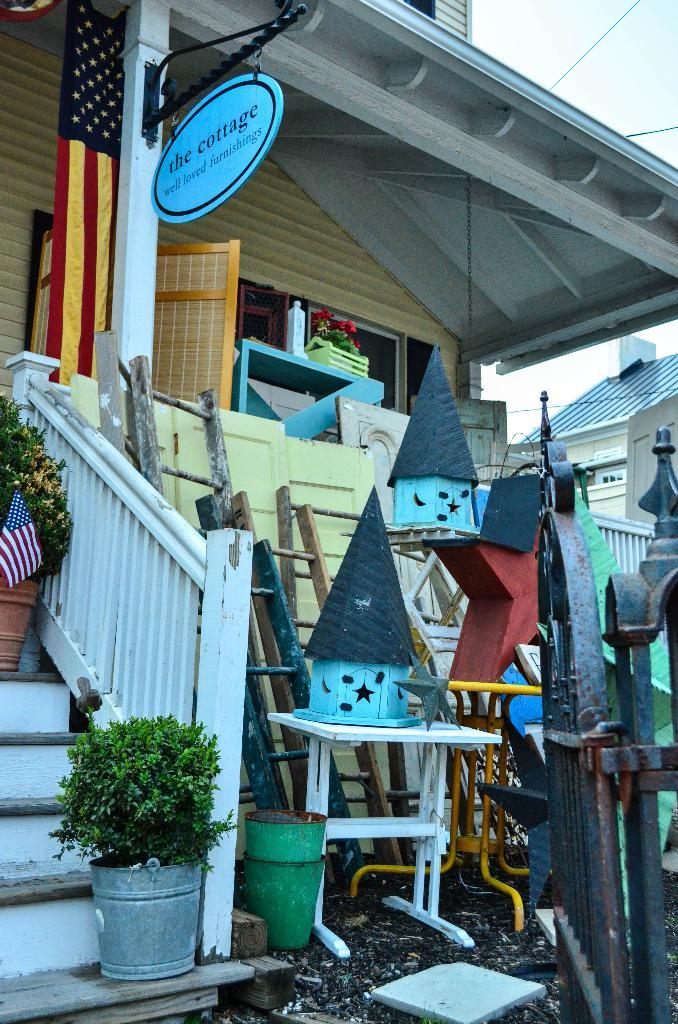What type of structures can be seen in the image? There are houses with windows in the image. What objects are present in the image that might be used for eating or working? There are tables in the image. What decorative or symbolic items can be seen in the image? There are flags in the image. What objects might be used for reaching higher places in the image? There are ladders in the image. What type of entrance or barrier is present in the image? There is a gate in the image. What can be seen in the background of the image? The sky is visible in the background of the image. What is the company's expansion strategy in the image? There is no mention of a company or its expansion strategy in the image; it features houses, tables, flags, ladders, a gate, and the sky. 